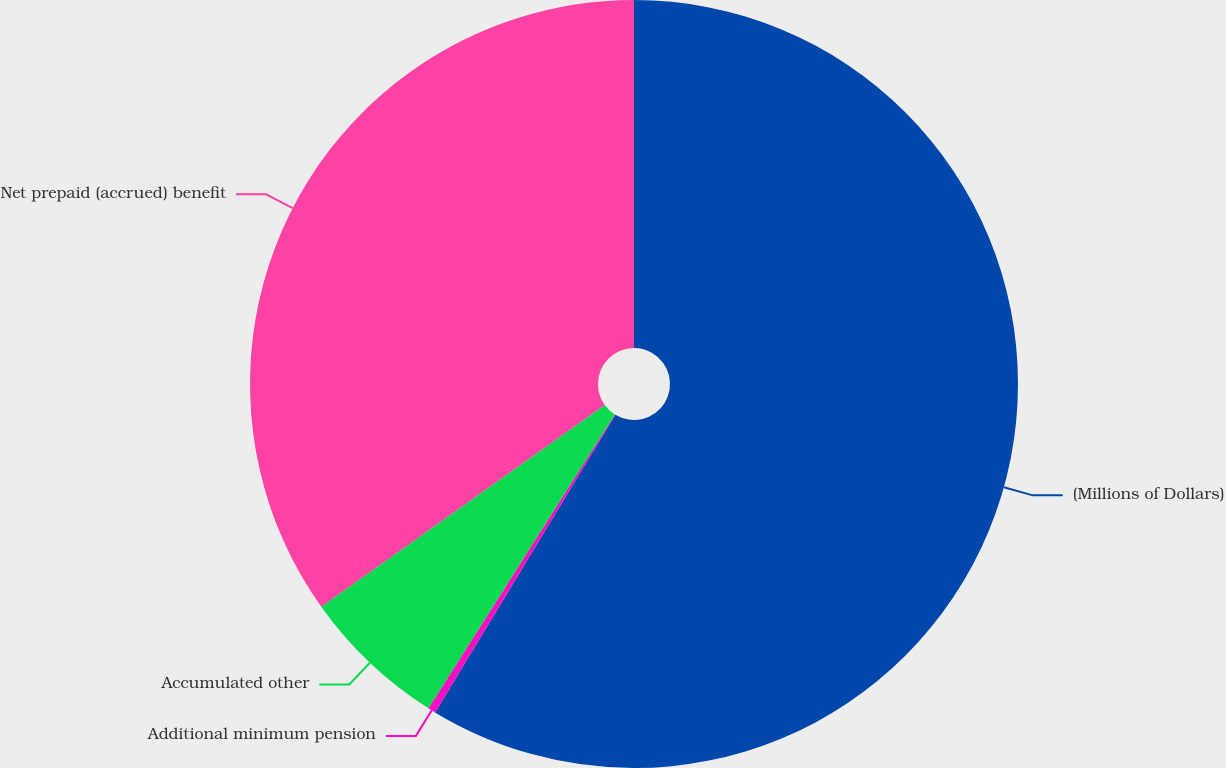Convert chart. <chart><loc_0><loc_0><loc_500><loc_500><pie_chart><fcel>(Millions of Dollars)<fcel>Additional minimum pension<fcel>Accumulated other<fcel>Net prepaid (accrued) benefit<nl><fcel>58.67%<fcel>0.32%<fcel>6.16%<fcel>34.85%<nl></chart> 